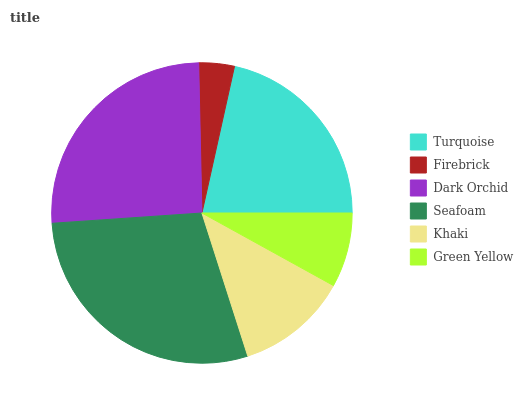Is Firebrick the minimum?
Answer yes or no. Yes. Is Seafoam the maximum?
Answer yes or no. Yes. Is Dark Orchid the minimum?
Answer yes or no. No. Is Dark Orchid the maximum?
Answer yes or no. No. Is Dark Orchid greater than Firebrick?
Answer yes or no. Yes. Is Firebrick less than Dark Orchid?
Answer yes or no. Yes. Is Firebrick greater than Dark Orchid?
Answer yes or no. No. Is Dark Orchid less than Firebrick?
Answer yes or no. No. Is Turquoise the high median?
Answer yes or no. Yes. Is Khaki the low median?
Answer yes or no. Yes. Is Seafoam the high median?
Answer yes or no. No. Is Seafoam the low median?
Answer yes or no. No. 